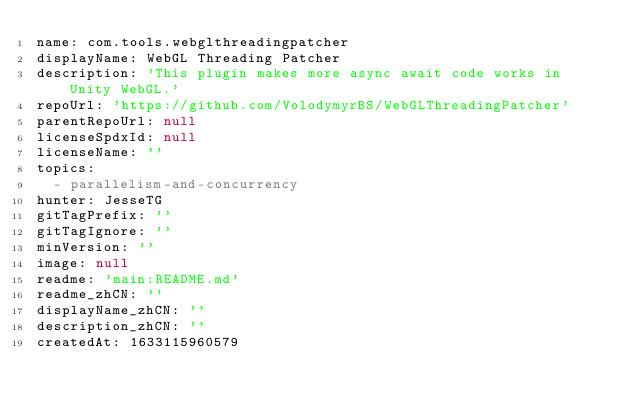Convert code to text. <code><loc_0><loc_0><loc_500><loc_500><_YAML_>name: com.tools.webglthreadingpatcher
displayName: WebGL Threading Patcher
description: 'This plugin makes more async await code works in Unity WebGL.'
repoUrl: 'https://github.com/VolodymyrBS/WebGLThreadingPatcher'
parentRepoUrl: null
licenseSpdxId: null
licenseName: ''
topics:
  - parallelism-and-concurrency
hunter: JesseTG
gitTagPrefix: ''
gitTagIgnore: ''
minVersion: ''
image: null
readme: 'main:README.md'
readme_zhCN: ''
displayName_zhCN: ''
description_zhCN: ''
createdAt: 1633115960579
</code> 